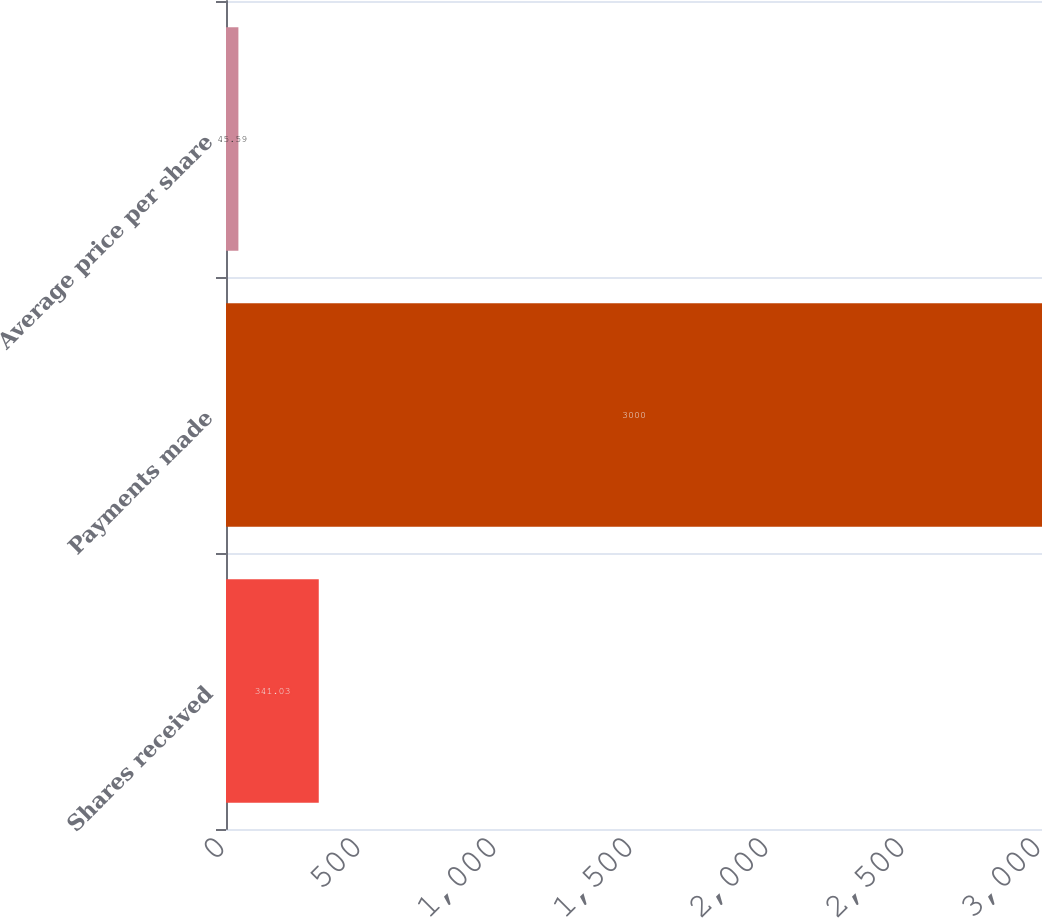Convert chart to OTSL. <chart><loc_0><loc_0><loc_500><loc_500><bar_chart><fcel>Shares received<fcel>Payments made<fcel>Average price per share<nl><fcel>341.03<fcel>3000<fcel>45.59<nl></chart> 